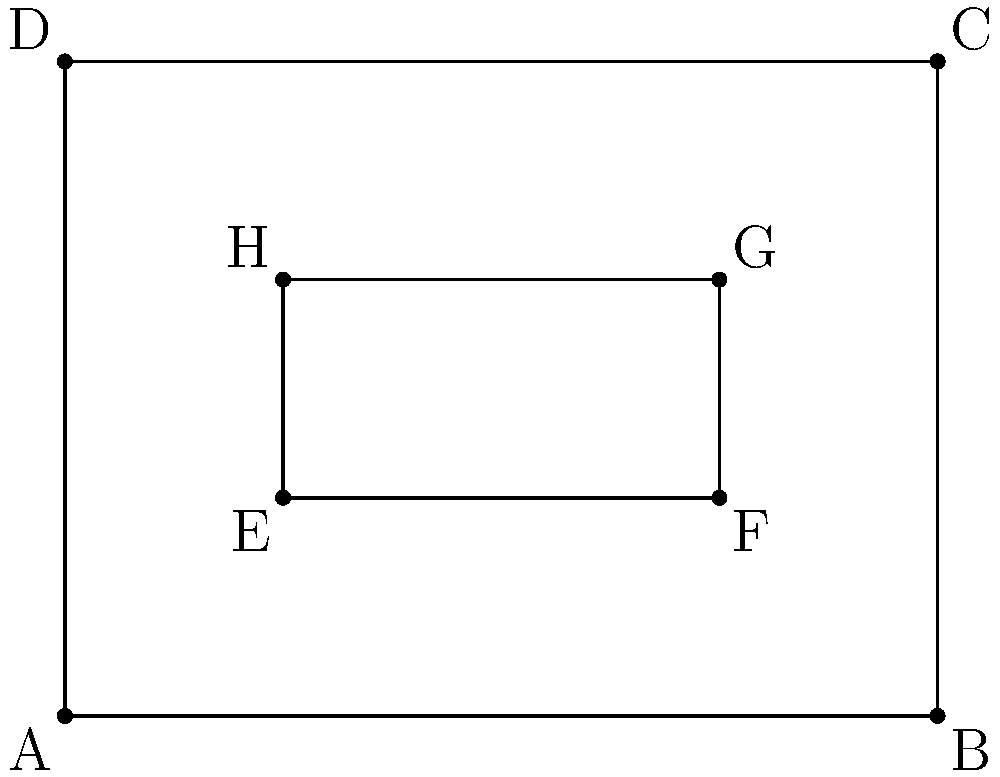In traditional Nigerian garden layouts, rectangular beds are often used for efficient space utilization. Consider the garden layout shown above, where ABCD represents the outer border of the garden and EFGH represents an inner flower bed. If AB = 4 meters, BC = 3 meters, EF = 2 meters, and FG = 1 meter, which pairs of shapes are congruent? To determine which pairs of shapes are congruent, we need to analyze the properties of the rectangles ABCD and EFGH:

1. For rectangle ABCD:
   - Length (AB) = 4 meters
   - Width (BC) = 3 meters

2. For rectangle EFGH:
   - Length (EF) = 2 meters
   - Width (FG) = 1 meter

3. To be congruent, shapes must have the same size and shape. For rectangles, this means they must have equal lengths and equal widths.

4. Let's compare the ratios of length to width for both rectangles:
   - For ABCD: $\frac{AB}{BC} = \frac{4}{3}$
   - For EFGH: $\frac{EF}{FG} = \frac{2}{1} = 2$

5. Since $\frac{4}{3} \neq 2$, the rectangles ABCD and EFGH are not congruent.

6. However, we can identify congruent pairs within each rectangle:
   - In ABCD: AB ≅ DC and AD ≅ BC (opposite sides of a rectangle are congruent)
   - In EFGH: EF ≅ HG and EH ≅ FG (opposite sides of a rectangle are congruent)

Therefore, the congruent pairs are: AB ≅ DC, AD ≅ BC, EF ≅ HG, and EH ≅ FG.
Answer: AB ≅ DC, AD ≅ BC, EF ≅ HG, EH ≅ FG 